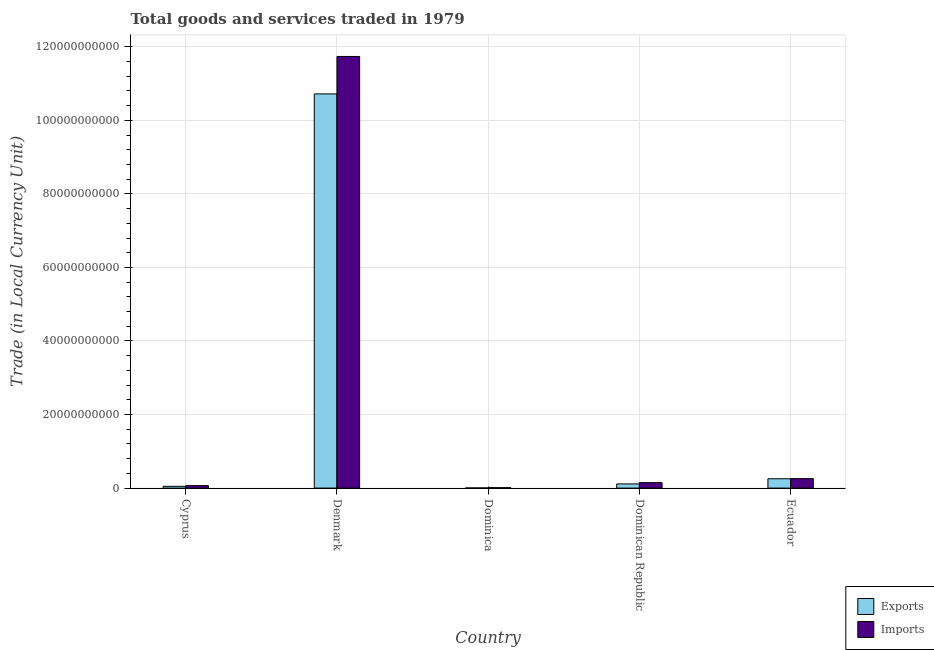Are the number of bars per tick equal to the number of legend labels?
Ensure brevity in your answer.  Yes. Are the number of bars on each tick of the X-axis equal?
Your answer should be very brief. Yes. How many bars are there on the 1st tick from the right?
Keep it short and to the point. 2. What is the label of the 1st group of bars from the left?
Make the answer very short. Cyprus. What is the export of goods and services in Denmark?
Give a very brief answer. 1.07e+11. Across all countries, what is the maximum export of goods and services?
Ensure brevity in your answer.  1.07e+11. Across all countries, what is the minimum export of goods and services?
Provide a succinct answer. 3.35e+07. In which country was the imports of goods and services minimum?
Your response must be concise. Dominica. What is the total export of goods and services in the graph?
Your response must be concise. 1.11e+11. What is the difference between the export of goods and services in Cyprus and that in Denmark?
Ensure brevity in your answer.  -1.07e+11. What is the difference between the imports of goods and services in Ecuador and the export of goods and services in Dominican Republic?
Give a very brief answer. 1.44e+09. What is the average imports of goods and services per country?
Offer a terse response. 2.44e+1. What is the difference between the imports of goods and services and export of goods and services in Dominica?
Keep it short and to the point. 7.53e+07. In how many countries, is the imports of goods and services greater than 12000000000 LCU?
Make the answer very short. 1. What is the ratio of the imports of goods and services in Dominica to that in Dominican Republic?
Your response must be concise. 0.07. Is the export of goods and services in Dominican Republic less than that in Ecuador?
Your answer should be compact. Yes. Is the difference between the export of goods and services in Dominican Republic and Ecuador greater than the difference between the imports of goods and services in Dominican Republic and Ecuador?
Make the answer very short. No. What is the difference between the highest and the second highest imports of goods and services?
Your response must be concise. 1.15e+11. What is the difference between the highest and the lowest export of goods and services?
Offer a very short reply. 1.07e+11. In how many countries, is the export of goods and services greater than the average export of goods and services taken over all countries?
Provide a short and direct response. 1. Is the sum of the export of goods and services in Dominican Republic and Ecuador greater than the maximum imports of goods and services across all countries?
Your answer should be compact. No. What does the 1st bar from the left in Dominica represents?
Offer a very short reply. Exports. What does the 1st bar from the right in Ecuador represents?
Your answer should be very brief. Imports. How many bars are there?
Make the answer very short. 10. Are all the bars in the graph horizontal?
Make the answer very short. No. How many countries are there in the graph?
Provide a short and direct response. 5. What is the difference between two consecutive major ticks on the Y-axis?
Provide a short and direct response. 2.00e+1. Are the values on the major ticks of Y-axis written in scientific E-notation?
Your answer should be very brief. No. Does the graph contain grids?
Ensure brevity in your answer.  Yes. How many legend labels are there?
Provide a short and direct response. 2. What is the title of the graph?
Offer a terse response. Total goods and services traded in 1979. What is the label or title of the Y-axis?
Provide a short and direct response. Trade (in Local Currency Unit). What is the Trade (in Local Currency Unit) in Exports in Cyprus?
Provide a succinct answer. 4.81e+08. What is the Trade (in Local Currency Unit) of Imports in Cyprus?
Provide a succinct answer. 6.86e+08. What is the Trade (in Local Currency Unit) in Exports in Denmark?
Provide a short and direct response. 1.07e+11. What is the Trade (in Local Currency Unit) in Imports in Denmark?
Your response must be concise. 1.17e+11. What is the Trade (in Local Currency Unit) in Exports in Dominica?
Your answer should be compact. 3.35e+07. What is the Trade (in Local Currency Unit) of Imports in Dominica?
Your answer should be compact. 1.09e+08. What is the Trade (in Local Currency Unit) in Exports in Dominican Republic?
Offer a very short reply. 1.13e+09. What is the Trade (in Local Currency Unit) in Imports in Dominican Republic?
Your answer should be compact. 1.48e+09. What is the Trade (in Local Currency Unit) of Exports in Ecuador?
Your answer should be very brief. 2.54e+09. What is the Trade (in Local Currency Unit) of Imports in Ecuador?
Provide a succinct answer. 2.57e+09. Across all countries, what is the maximum Trade (in Local Currency Unit) in Exports?
Give a very brief answer. 1.07e+11. Across all countries, what is the maximum Trade (in Local Currency Unit) in Imports?
Offer a terse response. 1.17e+11. Across all countries, what is the minimum Trade (in Local Currency Unit) of Exports?
Provide a short and direct response. 3.35e+07. Across all countries, what is the minimum Trade (in Local Currency Unit) of Imports?
Keep it short and to the point. 1.09e+08. What is the total Trade (in Local Currency Unit) in Exports in the graph?
Make the answer very short. 1.11e+11. What is the total Trade (in Local Currency Unit) of Imports in the graph?
Give a very brief answer. 1.22e+11. What is the difference between the Trade (in Local Currency Unit) of Exports in Cyprus and that in Denmark?
Offer a very short reply. -1.07e+11. What is the difference between the Trade (in Local Currency Unit) of Imports in Cyprus and that in Denmark?
Your answer should be very brief. -1.17e+11. What is the difference between the Trade (in Local Currency Unit) of Exports in Cyprus and that in Dominica?
Make the answer very short. 4.47e+08. What is the difference between the Trade (in Local Currency Unit) in Imports in Cyprus and that in Dominica?
Keep it short and to the point. 5.77e+08. What is the difference between the Trade (in Local Currency Unit) in Exports in Cyprus and that in Dominican Republic?
Provide a succinct answer. -6.54e+08. What is the difference between the Trade (in Local Currency Unit) in Imports in Cyprus and that in Dominican Republic?
Make the answer very short. -7.98e+08. What is the difference between the Trade (in Local Currency Unit) in Exports in Cyprus and that in Ecuador?
Give a very brief answer. -2.06e+09. What is the difference between the Trade (in Local Currency Unit) in Imports in Cyprus and that in Ecuador?
Your answer should be compact. -1.89e+09. What is the difference between the Trade (in Local Currency Unit) in Exports in Denmark and that in Dominica?
Your answer should be very brief. 1.07e+11. What is the difference between the Trade (in Local Currency Unit) in Imports in Denmark and that in Dominica?
Offer a very short reply. 1.17e+11. What is the difference between the Trade (in Local Currency Unit) of Exports in Denmark and that in Dominican Republic?
Your response must be concise. 1.06e+11. What is the difference between the Trade (in Local Currency Unit) in Imports in Denmark and that in Dominican Republic?
Offer a terse response. 1.16e+11. What is the difference between the Trade (in Local Currency Unit) in Exports in Denmark and that in Ecuador?
Keep it short and to the point. 1.05e+11. What is the difference between the Trade (in Local Currency Unit) of Imports in Denmark and that in Ecuador?
Your answer should be very brief. 1.15e+11. What is the difference between the Trade (in Local Currency Unit) in Exports in Dominica and that in Dominican Republic?
Your response must be concise. -1.10e+09. What is the difference between the Trade (in Local Currency Unit) of Imports in Dominica and that in Dominican Republic?
Offer a very short reply. -1.38e+09. What is the difference between the Trade (in Local Currency Unit) in Exports in Dominica and that in Ecuador?
Your answer should be compact. -2.50e+09. What is the difference between the Trade (in Local Currency Unit) of Imports in Dominica and that in Ecuador?
Provide a short and direct response. -2.47e+09. What is the difference between the Trade (in Local Currency Unit) in Exports in Dominican Republic and that in Ecuador?
Your response must be concise. -1.40e+09. What is the difference between the Trade (in Local Currency Unit) in Imports in Dominican Republic and that in Ecuador?
Ensure brevity in your answer.  -1.09e+09. What is the difference between the Trade (in Local Currency Unit) in Exports in Cyprus and the Trade (in Local Currency Unit) in Imports in Denmark?
Offer a terse response. -1.17e+11. What is the difference between the Trade (in Local Currency Unit) of Exports in Cyprus and the Trade (in Local Currency Unit) of Imports in Dominica?
Offer a terse response. 3.72e+08. What is the difference between the Trade (in Local Currency Unit) of Exports in Cyprus and the Trade (in Local Currency Unit) of Imports in Dominican Republic?
Your response must be concise. -1.00e+09. What is the difference between the Trade (in Local Currency Unit) of Exports in Cyprus and the Trade (in Local Currency Unit) of Imports in Ecuador?
Make the answer very short. -2.09e+09. What is the difference between the Trade (in Local Currency Unit) of Exports in Denmark and the Trade (in Local Currency Unit) of Imports in Dominica?
Give a very brief answer. 1.07e+11. What is the difference between the Trade (in Local Currency Unit) of Exports in Denmark and the Trade (in Local Currency Unit) of Imports in Dominican Republic?
Provide a short and direct response. 1.06e+11. What is the difference between the Trade (in Local Currency Unit) of Exports in Denmark and the Trade (in Local Currency Unit) of Imports in Ecuador?
Provide a short and direct response. 1.05e+11. What is the difference between the Trade (in Local Currency Unit) in Exports in Dominica and the Trade (in Local Currency Unit) in Imports in Dominican Republic?
Ensure brevity in your answer.  -1.45e+09. What is the difference between the Trade (in Local Currency Unit) of Exports in Dominica and the Trade (in Local Currency Unit) of Imports in Ecuador?
Keep it short and to the point. -2.54e+09. What is the difference between the Trade (in Local Currency Unit) of Exports in Dominican Republic and the Trade (in Local Currency Unit) of Imports in Ecuador?
Make the answer very short. -1.44e+09. What is the average Trade (in Local Currency Unit) of Exports per country?
Provide a short and direct response. 2.23e+1. What is the average Trade (in Local Currency Unit) in Imports per country?
Offer a terse response. 2.44e+1. What is the difference between the Trade (in Local Currency Unit) of Exports and Trade (in Local Currency Unit) of Imports in Cyprus?
Keep it short and to the point. -2.05e+08. What is the difference between the Trade (in Local Currency Unit) in Exports and Trade (in Local Currency Unit) in Imports in Denmark?
Offer a terse response. -1.02e+1. What is the difference between the Trade (in Local Currency Unit) of Exports and Trade (in Local Currency Unit) of Imports in Dominica?
Your answer should be very brief. -7.53e+07. What is the difference between the Trade (in Local Currency Unit) in Exports and Trade (in Local Currency Unit) in Imports in Dominican Republic?
Ensure brevity in your answer.  -3.49e+08. What is the difference between the Trade (in Local Currency Unit) in Exports and Trade (in Local Currency Unit) in Imports in Ecuador?
Provide a succinct answer. -3.73e+07. What is the ratio of the Trade (in Local Currency Unit) in Exports in Cyprus to that in Denmark?
Your answer should be compact. 0. What is the ratio of the Trade (in Local Currency Unit) of Imports in Cyprus to that in Denmark?
Offer a very short reply. 0.01. What is the ratio of the Trade (in Local Currency Unit) in Exports in Cyprus to that in Dominica?
Provide a succinct answer. 14.35. What is the ratio of the Trade (in Local Currency Unit) of Imports in Cyprus to that in Dominica?
Your answer should be very brief. 6.31. What is the ratio of the Trade (in Local Currency Unit) of Exports in Cyprus to that in Dominican Republic?
Offer a terse response. 0.42. What is the ratio of the Trade (in Local Currency Unit) in Imports in Cyprus to that in Dominican Republic?
Your answer should be very brief. 0.46. What is the ratio of the Trade (in Local Currency Unit) of Exports in Cyprus to that in Ecuador?
Give a very brief answer. 0.19. What is the ratio of the Trade (in Local Currency Unit) in Imports in Cyprus to that in Ecuador?
Your answer should be very brief. 0.27. What is the ratio of the Trade (in Local Currency Unit) in Exports in Denmark to that in Dominica?
Give a very brief answer. 3199.6. What is the ratio of the Trade (in Local Currency Unit) of Imports in Denmark to that in Dominica?
Ensure brevity in your answer.  1078.76. What is the ratio of the Trade (in Local Currency Unit) in Exports in Denmark to that in Dominican Republic?
Make the answer very short. 94.45. What is the ratio of the Trade (in Local Currency Unit) of Imports in Denmark to that in Dominican Republic?
Ensure brevity in your answer.  79.07. What is the ratio of the Trade (in Local Currency Unit) in Exports in Denmark to that in Ecuador?
Provide a succinct answer. 42.24. What is the ratio of the Trade (in Local Currency Unit) of Imports in Denmark to that in Ecuador?
Give a very brief answer. 45.59. What is the ratio of the Trade (in Local Currency Unit) of Exports in Dominica to that in Dominican Republic?
Your answer should be very brief. 0.03. What is the ratio of the Trade (in Local Currency Unit) in Imports in Dominica to that in Dominican Republic?
Keep it short and to the point. 0.07. What is the ratio of the Trade (in Local Currency Unit) in Exports in Dominica to that in Ecuador?
Offer a very short reply. 0.01. What is the ratio of the Trade (in Local Currency Unit) in Imports in Dominica to that in Ecuador?
Your answer should be compact. 0.04. What is the ratio of the Trade (in Local Currency Unit) of Exports in Dominican Republic to that in Ecuador?
Your answer should be compact. 0.45. What is the ratio of the Trade (in Local Currency Unit) of Imports in Dominican Republic to that in Ecuador?
Provide a succinct answer. 0.58. What is the difference between the highest and the second highest Trade (in Local Currency Unit) of Exports?
Your response must be concise. 1.05e+11. What is the difference between the highest and the second highest Trade (in Local Currency Unit) of Imports?
Ensure brevity in your answer.  1.15e+11. What is the difference between the highest and the lowest Trade (in Local Currency Unit) of Exports?
Your answer should be compact. 1.07e+11. What is the difference between the highest and the lowest Trade (in Local Currency Unit) of Imports?
Make the answer very short. 1.17e+11. 